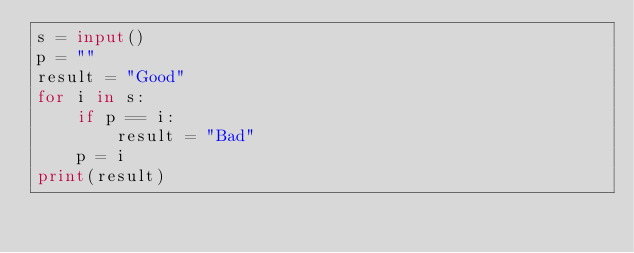Convert code to text. <code><loc_0><loc_0><loc_500><loc_500><_Python_>s = input()
p = ""
result = "Good"
for i in s:
    if p == i:
        result = "Bad"
    p = i
print(result)</code> 